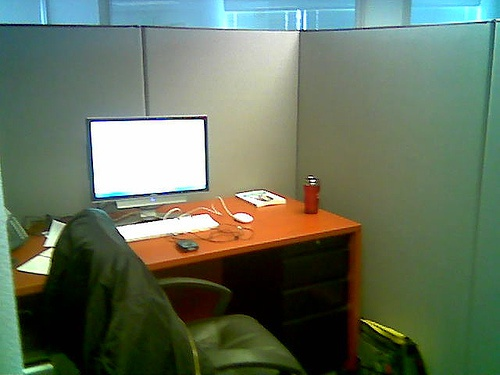Describe the objects in this image and their specific colors. I can see chair in lightblue, black, and darkgreen tones, tv in lightblue, white, black, darkgray, and gray tones, keyboard in lightblue, white, beige, black, and darkgray tones, book in lightblue, ivory, khaki, tan, and darkgray tones, and cup in lightblue, maroon, and brown tones in this image. 